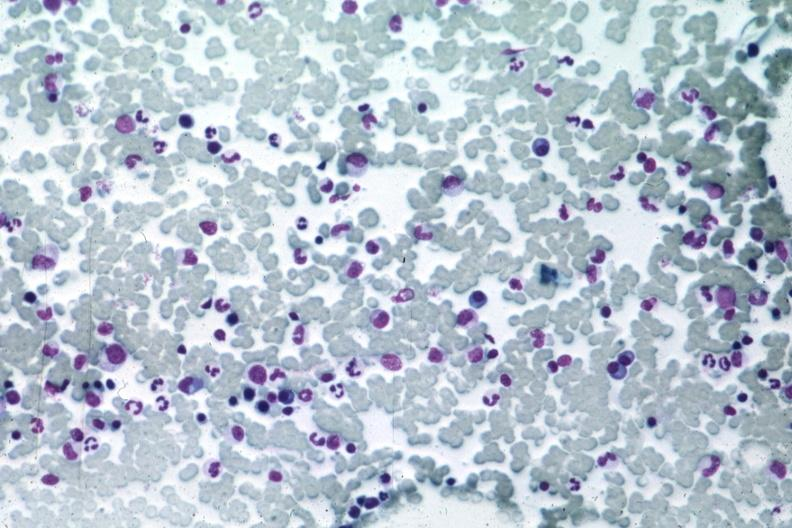s multiple myeloma present?
Answer the question using a single word or phrase. Yes 